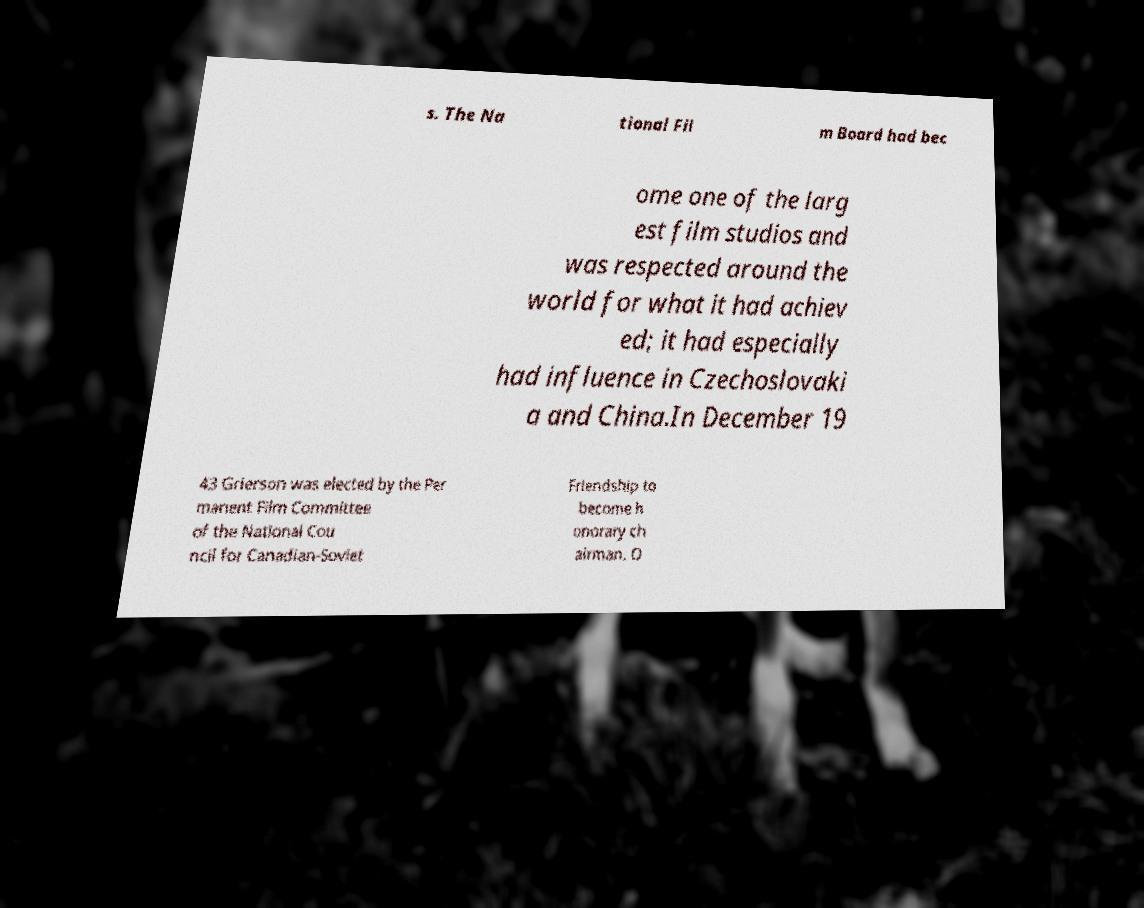Please read and relay the text visible in this image. What does it say? s. The Na tional Fil m Board had bec ome one of the larg est film studios and was respected around the world for what it had achiev ed; it had especially had influence in Czechoslovaki a and China.In December 19 43 Grierson was elected by the Per manent Film Committee of the National Cou ncil for Canadian-Soviet Friendship to become h onorary ch airman. O 